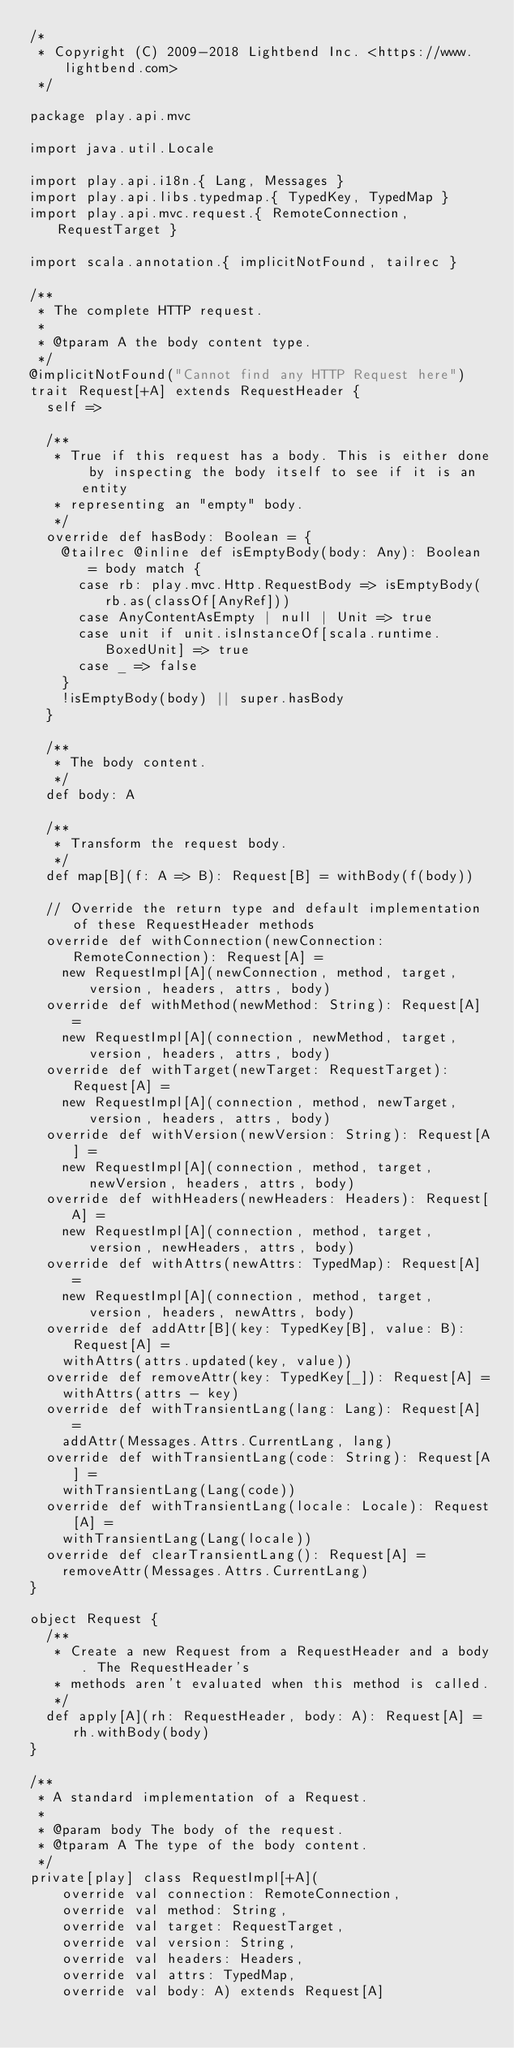<code> <loc_0><loc_0><loc_500><loc_500><_Scala_>/*
 * Copyright (C) 2009-2018 Lightbend Inc. <https://www.lightbend.com>
 */

package play.api.mvc

import java.util.Locale

import play.api.i18n.{ Lang, Messages }
import play.api.libs.typedmap.{ TypedKey, TypedMap }
import play.api.mvc.request.{ RemoteConnection, RequestTarget }

import scala.annotation.{ implicitNotFound, tailrec }

/**
 * The complete HTTP request.
 *
 * @tparam A the body content type.
 */
@implicitNotFound("Cannot find any HTTP Request here")
trait Request[+A] extends RequestHeader {
  self =>

  /**
   * True if this request has a body. This is either done by inspecting the body itself to see if it is an entity
   * representing an "empty" body.
   */
  override def hasBody: Boolean = {
    @tailrec @inline def isEmptyBody(body: Any): Boolean = body match {
      case rb: play.mvc.Http.RequestBody => isEmptyBody(rb.as(classOf[AnyRef]))
      case AnyContentAsEmpty | null | Unit => true
      case unit if unit.isInstanceOf[scala.runtime.BoxedUnit] => true
      case _ => false
    }
    !isEmptyBody(body) || super.hasBody
  }

  /**
   * The body content.
   */
  def body: A

  /**
   * Transform the request body.
   */
  def map[B](f: A => B): Request[B] = withBody(f(body))

  // Override the return type and default implementation of these RequestHeader methods
  override def withConnection(newConnection: RemoteConnection): Request[A] =
    new RequestImpl[A](newConnection, method, target, version, headers, attrs, body)
  override def withMethod(newMethod: String): Request[A] =
    new RequestImpl[A](connection, newMethod, target, version, headers, attrs, body)
  override def withTarget(newTarget: RequestTarget): Request[A] =
    new RequestImpl[A](connection, method, newTarget, version, headers, attrs, body)
  override def withVersion(newVersion: String): Request[A] =
    new RequestImpl[A](connection, method, target, newVersion, headers, attrs, body)
  override def withHeaders(newHeaders: Headers): Request[A] =
    new RequestImpl[A](connection, method, target, version, newHeaders, attrs, body)
  override def withAttrs(newAttrs: TypedMap): Request[A] =
    new RequestImpl[A](connection, method, target, version, headers, newAttrs, body)
  override def addAttr[B](key: TypedKey[B], value: B): Request[A] =
    withAttrs(attrs.updated(key, value))
  override def removeAttr(key: TypedKey[_]): Request[A] =
    withAttrs(attrs - key)
  override def withTransientLang(lang: Lang): Request[A] =
    addAttr(Messages.Attrs.CurrentLang, lang)
  override def withTransientLang(code: String): Request[A] =
    withTransientLang(Lang(code))
  override def withTransientLang(locale: Locale): Request[A] =
    withTransientLang(Lang(locale))
  override def clearTransientLang(): Request[A] =
    removeAttr(Messages.Attrs.CurrentLang)
}

object Request {
  /**
   * Create a new Request from a RequestHeader and a body. The RequestHeader's
   * methods aren't evaluated when this method is called.
   */
  def apply[A](rh: RequestHeader, body: A): Request[A] = rh.withBody(body)
}

/**
 * A standard implementation of a Request.
 *
 * @param body The body of the request.
 * @tparam A The type of the body content.
 */
private[play] class RequestImpl[+A](
    override val connection: RemoteConnection,
    override val method: String,
    override val target: RequestTarget,
    override val version: String,
    override val headers: Headers,
    override val attrs: TypedMap,
    override val body: A) extends Request[A]</code> 